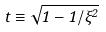Convert formula to latex. <formula><loc_0><loc_0><loc_500><loc_500>t \equiv \sqrt { 1 - 1 / \xi ^ { 2 } }</formula> 